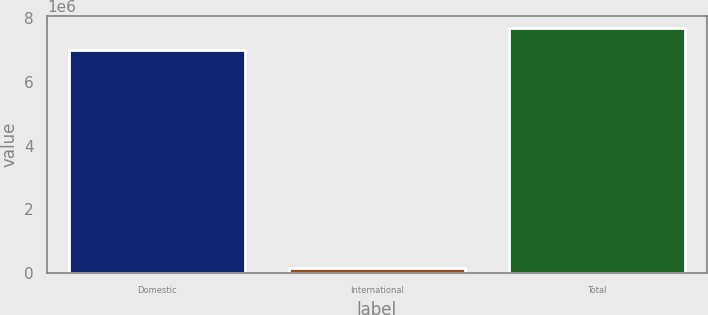Convert chart. <chart><loc_0><loc_0><loc_500><loc_500><bar_chart><fcel>Domestic<fcel>International<fcel>Total<nl><fcel>6.99161e+06<fcel>170195<fcel>7.69078e+06<nl></chart> 